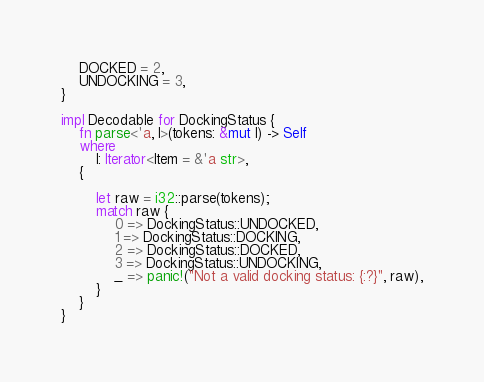<code> <loc_0><loc_0><loc_500><loc_500><_Rust_>    DOCKED = 2,
    UNDOCKING = 3,
}

impl Decodable for DockingStatus {
    fn parse<'a, I>(tokens: &mut I) -> Self
    where
        I: Iterator<Item = &'a str>,
    {

        let raw = i32::parse(tokens);
        match raw {
            0 => DockingStatus::UNDOCKED,
            1 => DockingStatus::DOCKING,
            2 => DockingStatus::DOCKED,
            3 => DockingStatus::UNDOCKING,
            _ => panic!("Not a valid docking status: {:?}", raw),
        }
    }
}
</code> 